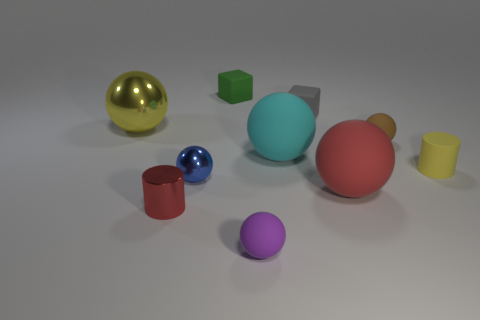The object that is the same color as the tiny metal cylinder is what shape?
Offer a very short reply. Sphere. What number of blue things are big metal spheres or small metallic spheres?
Provide a succinct answer. 1. What size is the cyan object?
Ensure brevity in your answer.  Large. Is the number of large rubber objects right of the gray object greater than the number of brown matte objects?
Provide a short and direct response. No. What number of gray things are on the left side of the purple object?
Your answer should be very brief. 0. Is there a gray rubber cube of the same size as the purple matte sphere?
Provide a short and direct response. Yes. There is another large shiny thing that is the same shape as the brown object; what is its color?
Offer a very short reply. Yellow. Is the size of the cylinder that is in front of the tiny yellow thing the same as the metal object that is behind the cyan rubber ball?
Provide a succinct answer. No. Is there a gray matte thing that has the same shape as the yellow shiny thing?
Your response must be concise. No. Are there the same number of tiny green matte cubes that are behind the green thing and small brown matte balls?
Your response must be concise. No. 